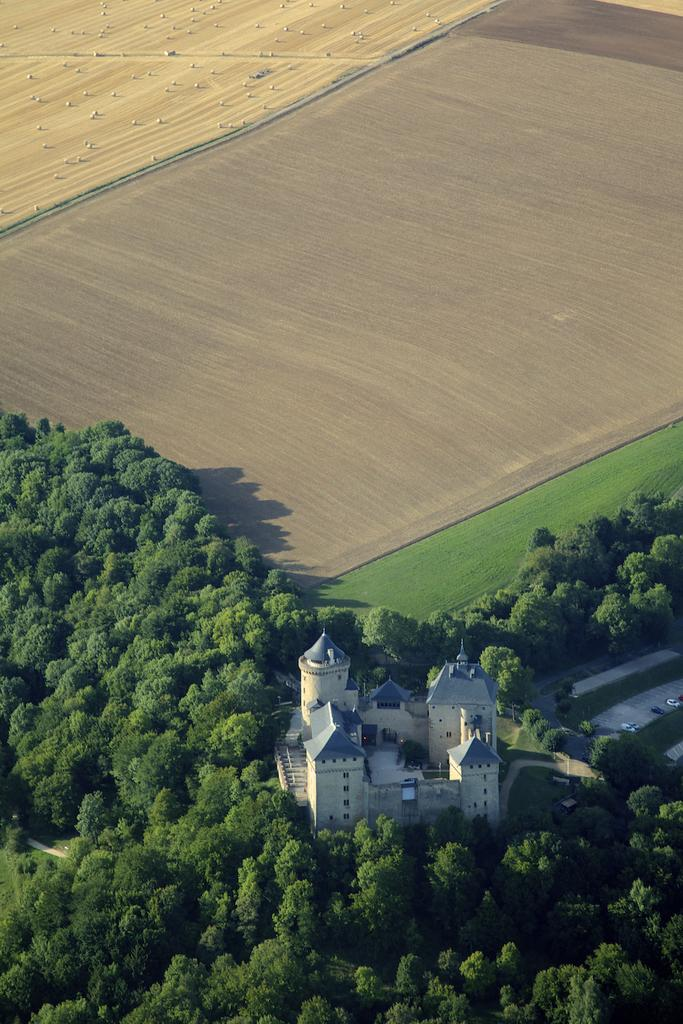What is the main structure in the image? There is a castle in the image. Where is the castle situated in relation to the trees? The castle is located between trees. What colors are used to depict the castle? The castle is white and blue in color. What type of terrain is visible at the top of the image? There is grass and land visible at the top of the image. Can you see a table with plastic chairs near the castle in the image? There is no table or plastic chairs visible in the image; it only features a castle between trees. 